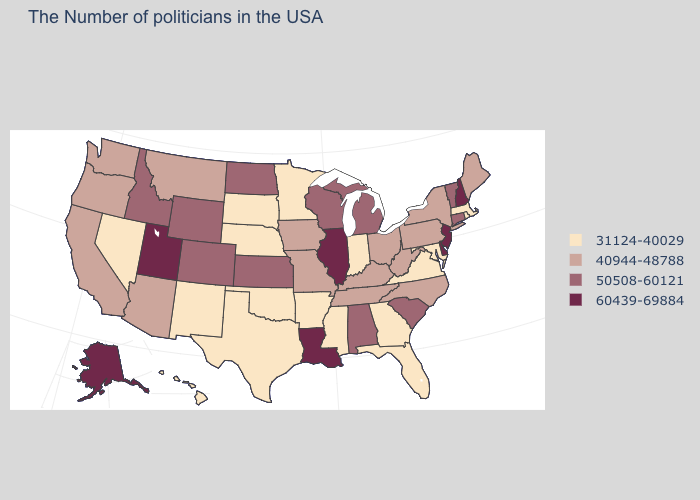Is the legend a continuous bar?
Write a very short answer. No. What is the value of West Virginia?
Concise answer only. 40944-48788. What is the value of Indiana?
Quick response, please. 31124-40029. Among the states that border New Hampshire , which have the lowest value?
Concise answer only. Massachusetts. Is the legend a continuous bar?
Answer briefly. No. Does Ohio have the highest value in the MidWest?
Short answer required. No. Does the map have missing data?
Quick response, please. No. Among the states that border Utah , which have the highest value?
Quick response, please. Wyoming, Colorado, Idaho. How many symbols are there in the legend?
Short answer required. 4. Name the states that have a value in the range 31124-40029?
Concise answer only. Massachusetts, Rhode Island, Maryland, Virginia, Florida, Georgia, Indiana, Mississippi, Arkansas, Minnesota, Nebraska, Oklahoma, Texas, South Dakota, New Mexico, Nevada, Hawaii. What is the value of West Virginia?
Write a very short answer. 40944-48788. What is the lowest value in states that border Maryland?
Short answer required. 31124-40029. Does Illinois have the highest value in the MidWest?
Answer briefly. Yes. 